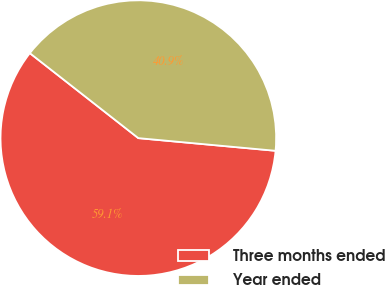<chart> <loc_0><loc_0><loc_500><loc_500><pie_chart><fcel>Three months ended<fcel>Year ended<nl><fcel>59.11%<fcel>40.89%<nl></chart> 